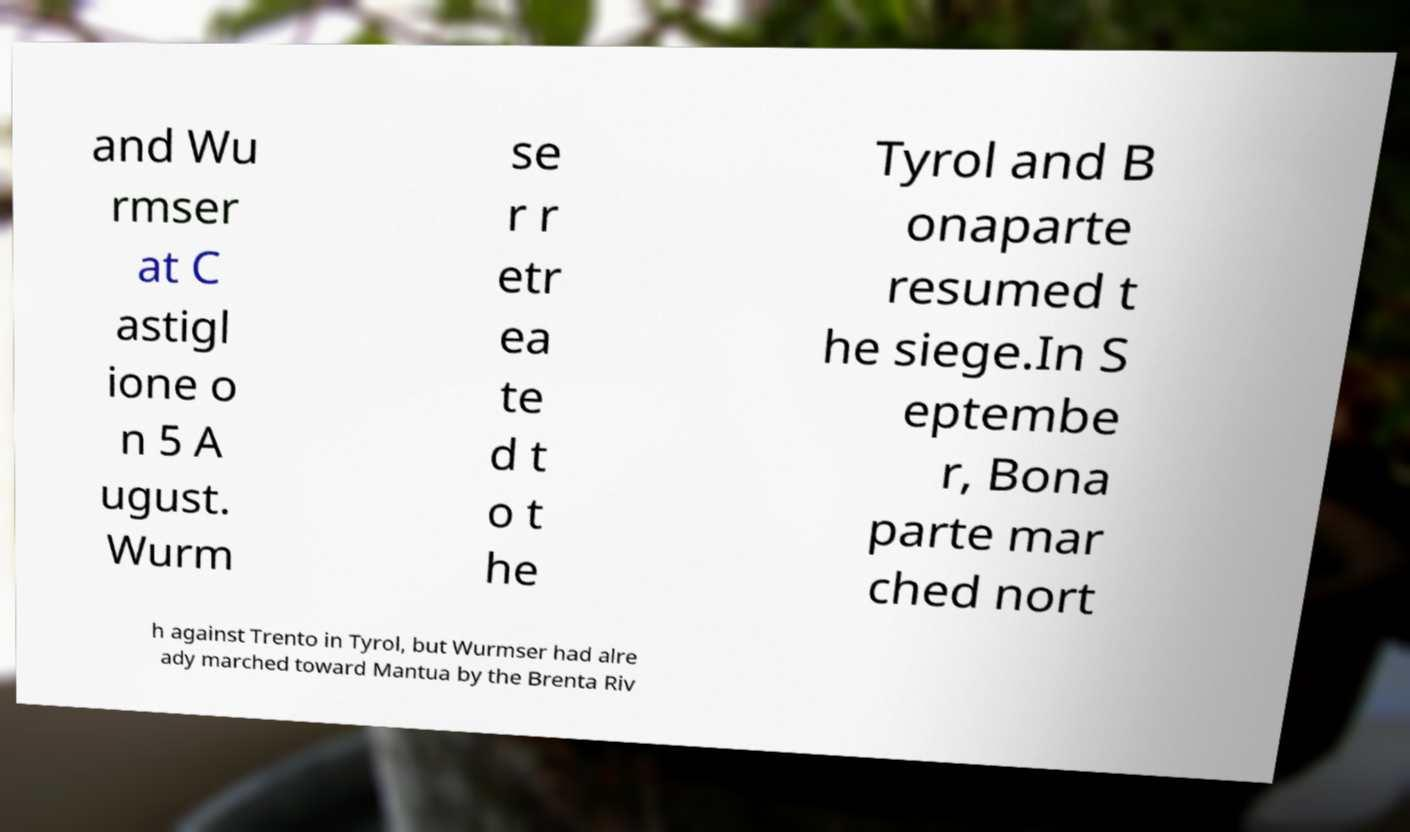Can you accurately transcribe the text from the provided image for me? and Wu rmser at C astigl ione o n 5 A ugust. Wurm se r r etr ea te d t o t he Tyrol and B onaparte resumed t he siege.In S eptembe r, Bona parte mar ched nort h against Trento in Tyrol, but Wurmser had alre ady marched toward Mantua by the Brenta Riv 